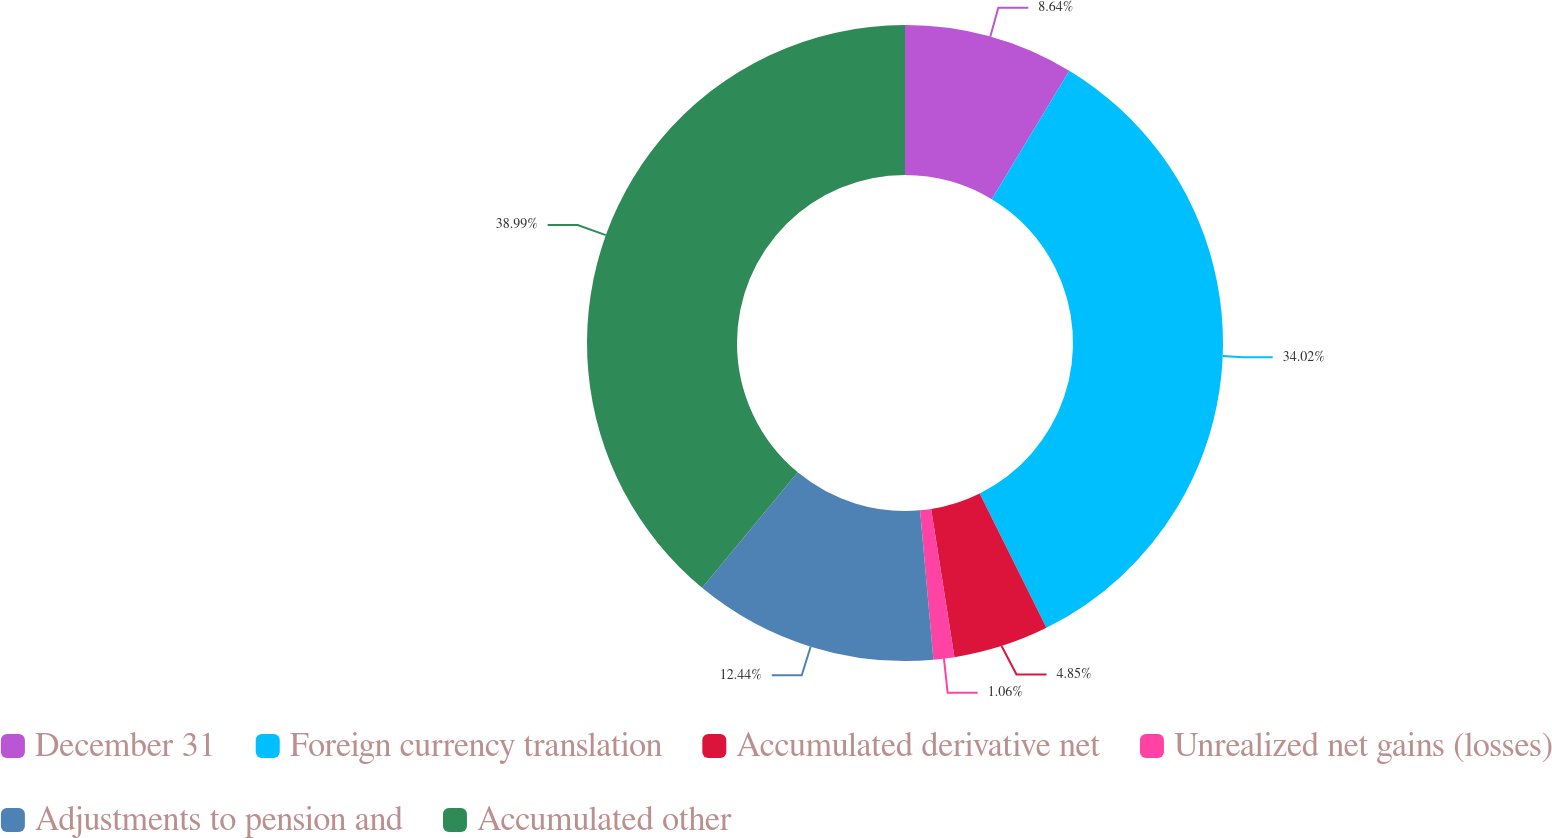<chart> <loc_0><loc_0><loc_500><loc_500><pie_chart><fcel>December 31<fcel>Foreign currency translation<fcel>Accumulated derivative net<fcel>Unrealized net gains (losses)<fcel>Adjustments to pension and<fcel>Accumulated other<nl><fcel>8.64%<fcel>34.02%<fcel>4.85%<fcel>1.06%<fcel>12.44%<fcel>38.98%<nl></chart> 